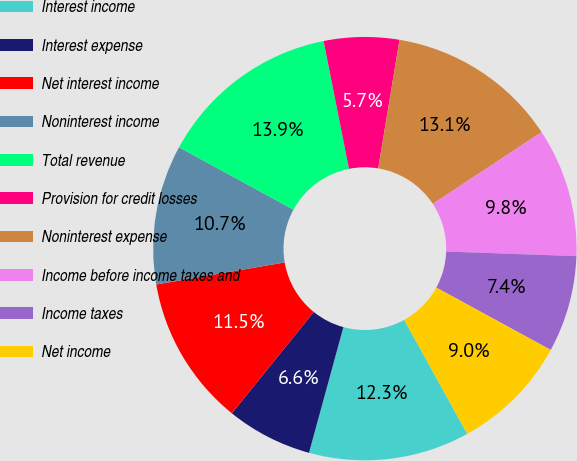<chart> <loc_0><loc_0><loc_500><loc_500><pie_chart><fcel>Interest income<fcel>Interest expense<fcel>Net interest income<fcel>Noninterest income<fcel>Total revenue<fcel>Provision for credit losses<fcel>Noninterest expense<fcel>Income before income taxes and<fcel>Income taxes<fcel>Net income<nl><fcel>12.29%<fcel>6.56%<fcel>11.48%<fcel>10.66%<fcel>13.93%<fcel>5.74%<fcel>13.11%<fcel>9.84%<fcel>7.38%<fcel>9.02%<nl></chart> 